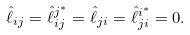<formula> <loc_0><loc_0><loc_500><loc_500>\hat { \ell } _ { i j } = \hat { \ell } ^ { j ^ { * } } _ { i j } = \hat { \ell } _ { j i } = \hat { \ell } ^ { i ^ { * } } _ { j i } = 0 .</formula> 